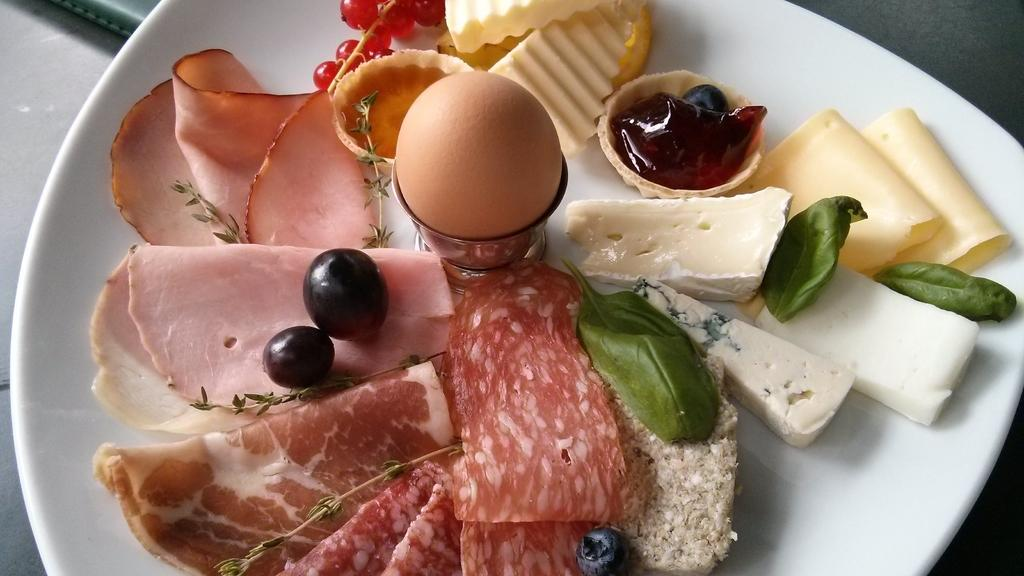What object is present on the table in the image? There is a plate on the table in the image. What is on the plate? There are fruits and leafy vegetables on the plate. Can you describe the type of food on the plate? There is food on the plate, which includes fruits and leafy vegetables. How does the plate contribute to world peace in the image? The plate does not contribute to world peace in the image; it is simply a plate with food on it. 